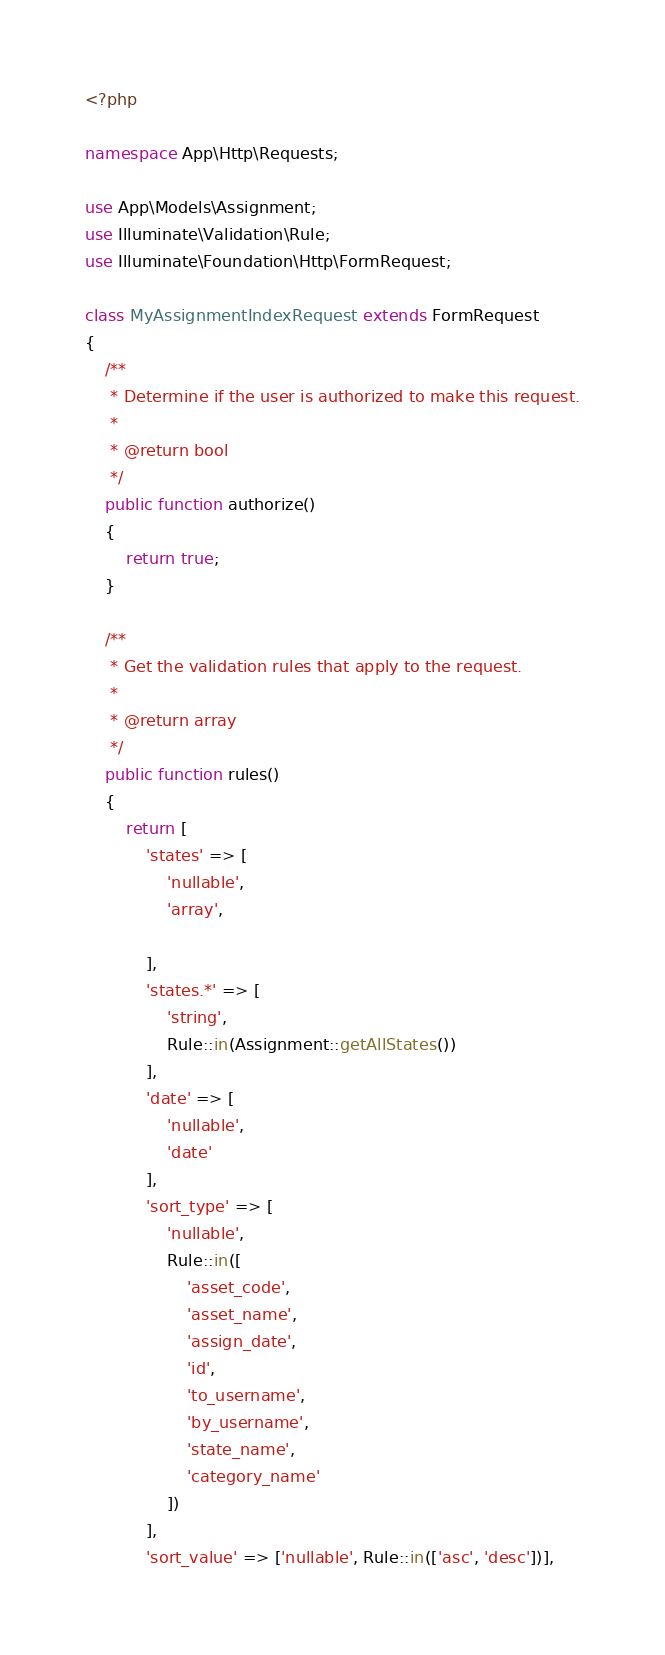<code> <loc_0><loc_0><loc_500><loc_500><_PHP_><?php

namespace App\Http\Requests;

use App\Models\Assignment;
use Illuminate\Validation\Rule;
use Illuminate\Foundation\Http\FormRequest;

class MyAssignmentIndexRequest extends FormRequest
{
    /**
     * Determine if the user is authorized to make this request.
     *
     * @return bool
     */
    public function authorize()
    {
        return true;
    }

    /**
     * Get the validation rules that apply to the request.
     *
     * @return array
     */
    public function rules()
    {
        return [
            'states' => [
                'nullable',
                'array',

            ],
            'states.*' => [
                'string',
                Rule::in(Assignment::getAllStates())
            ],
            'date' => [
                'nullable',
                'date'
            ],
            'sort_type' => [
                'nullable',
                Rule::in([
                    'asset_code',
                    'asset_name',
                    'assign_date',
                    'id',
                    'to_username',
                    'by_username',
                    'state_name',
                    'category_name'
                ])
            ],
            'sort_value' => ['nullable', Rule::in(['asc', 'desc'])],</code> 